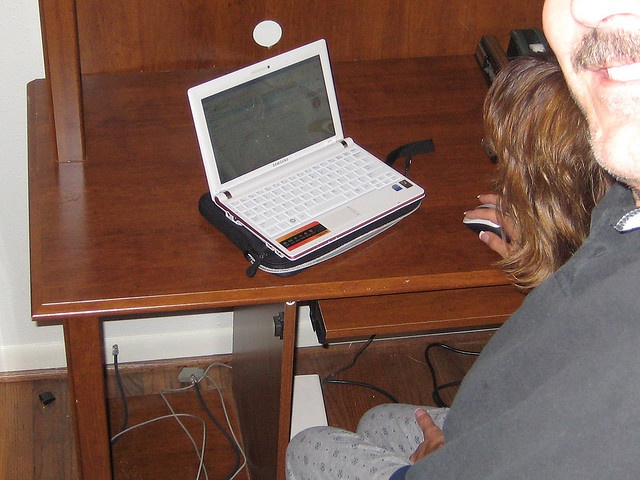Describe the objects in this image and their specific colors. I can see people in lightgray, gray, and white tones, laptop in lightgray, gray, darkgray, and black tones, people in lightgray, maroon, gray, and brown tones, and mouse in lightgray, black, and gray tones in this image. 